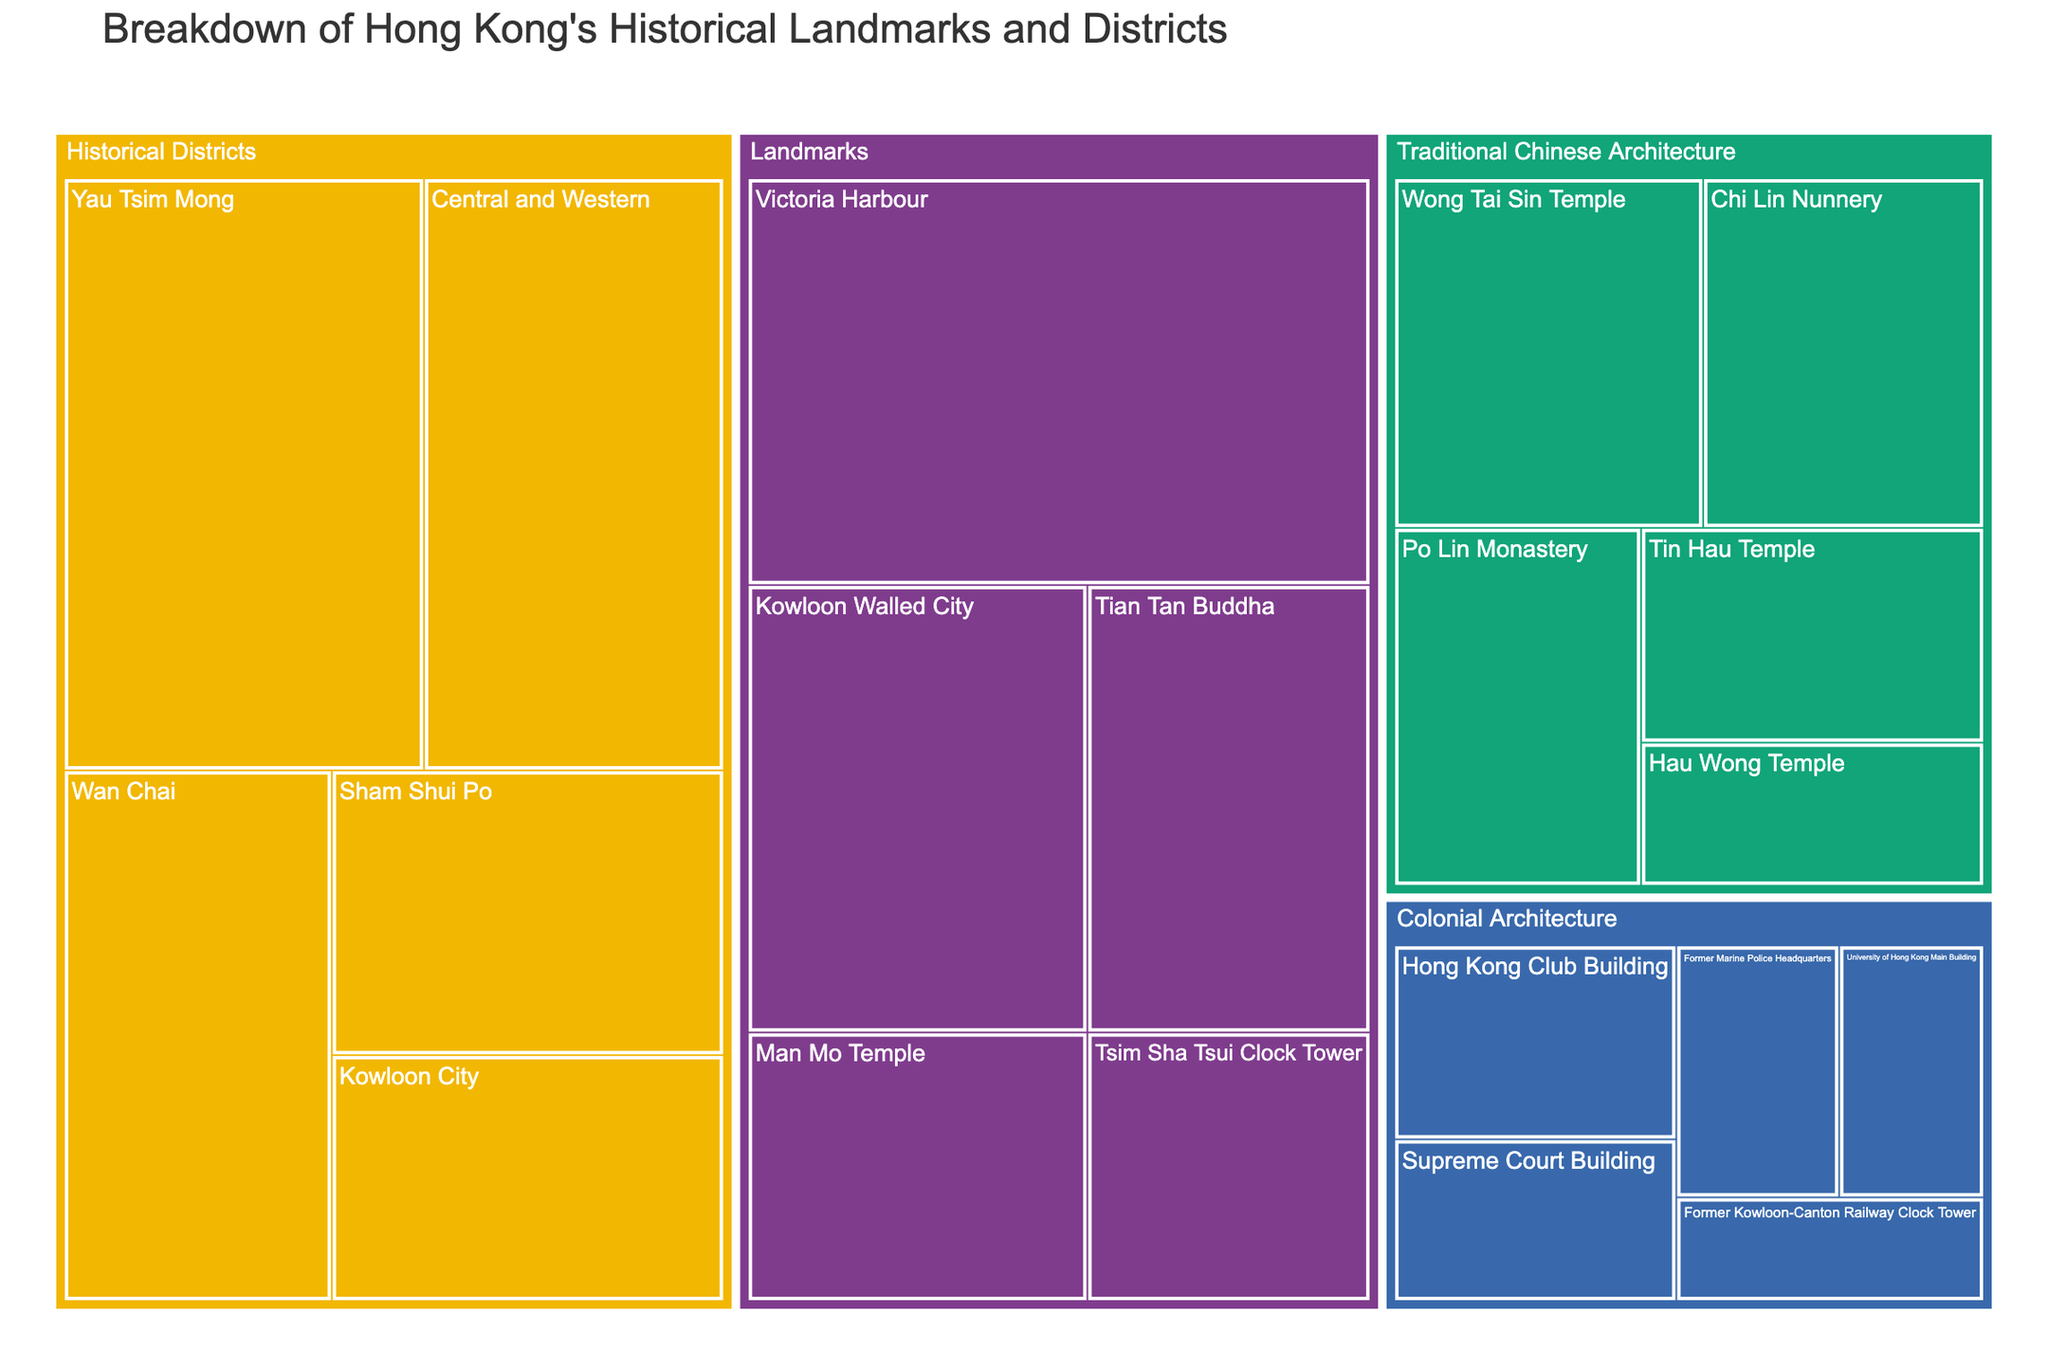What's the title of the treemap? The title of the treemap is typically found at the top of the figure, often in larger or bold font. It provides a summary of what the figure represents.
Answer: Breakdown of Hong Kong's Historical Landmarks and Districts Which historical district has the highest value? To find this, you look for the largest box under the "Historical Districts" category in the treemap, as the size indicates the value. Yau Tsim Mong has the largest box.
Answer: Yau Tsim Mong What is the combined value of all the "Colonial Architecture" subcategories? Sum the values of all subcategories under "Colonial Architecture" (12 + 10 + 8 + 7 + 9). The sum is 46.
Answer: 46 Which category has the highest total value? To determine this, sum the values of all subcategories within each category and compare. "Historical Districts" has total sum 146, "Landmarks" 138, "Colonial Architecture" 46, and "Traditional Chinese Architecture" 85. Historical Districts have the highest total.
Answer: Historical Districts How does the value of Victoria Harbour compare to the value of Tian Tan Buddha? Compare the values given: Victoria Harbour has a value of 50, and Tian Tan Buddha has a value of 25. Victoria Harbour's value is double that of Tian Tan Buddha.
Answer: Victoria Harbour is double the value of Tian Tan Buddha What is the average value of the landmarks listed in the figure? To find the average, sum the values of all landmarks (50 + 30 + 15 + 18 + 25) and divide by the number of landmarks (5). The sum is 138, and the average is 138/5 = 27.6.
Answer: 27.6 Which category has the smallest individual subcategory value and what is that value? Look for the smallest box under each main category. "Colonial Architecture" has a subcategory "Former Kowloon-Canton Railway Clock Tower" with the smallest value of 7.
Answer: Colonial Architecture, 7 What are the values associated with Traditional Chinese Architecture subcategories? Identify the values of all subcategories under "Traditional Chinese Architecture" in the treemap. Chi Lin Nunnery (20), Wong Tai Sin Temple (22), Po Lin Monastery (18), Tin Hau Temple (15), Hau Wong Temple (10).
Answer: 20, 22, 18, 15, 10 By how much does Kowloon Walled City's value exceed that of Tsim Sha Tsui Clock Tower? Subtract the value of Tsim Sha Tsui Clock Tower from Kowloon Walled City's value (30 - 15). The difference is 15.
Answer: 15 